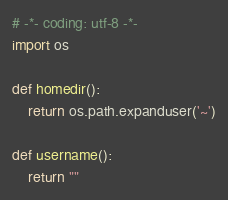<code> <loc_0><loc_0><loc_500><loc_500><_Python_># -*- coding: utf-8 -*-
import os

def homedir():
    return os.path.expanduser('~')

def username():
    return ""

</code> 